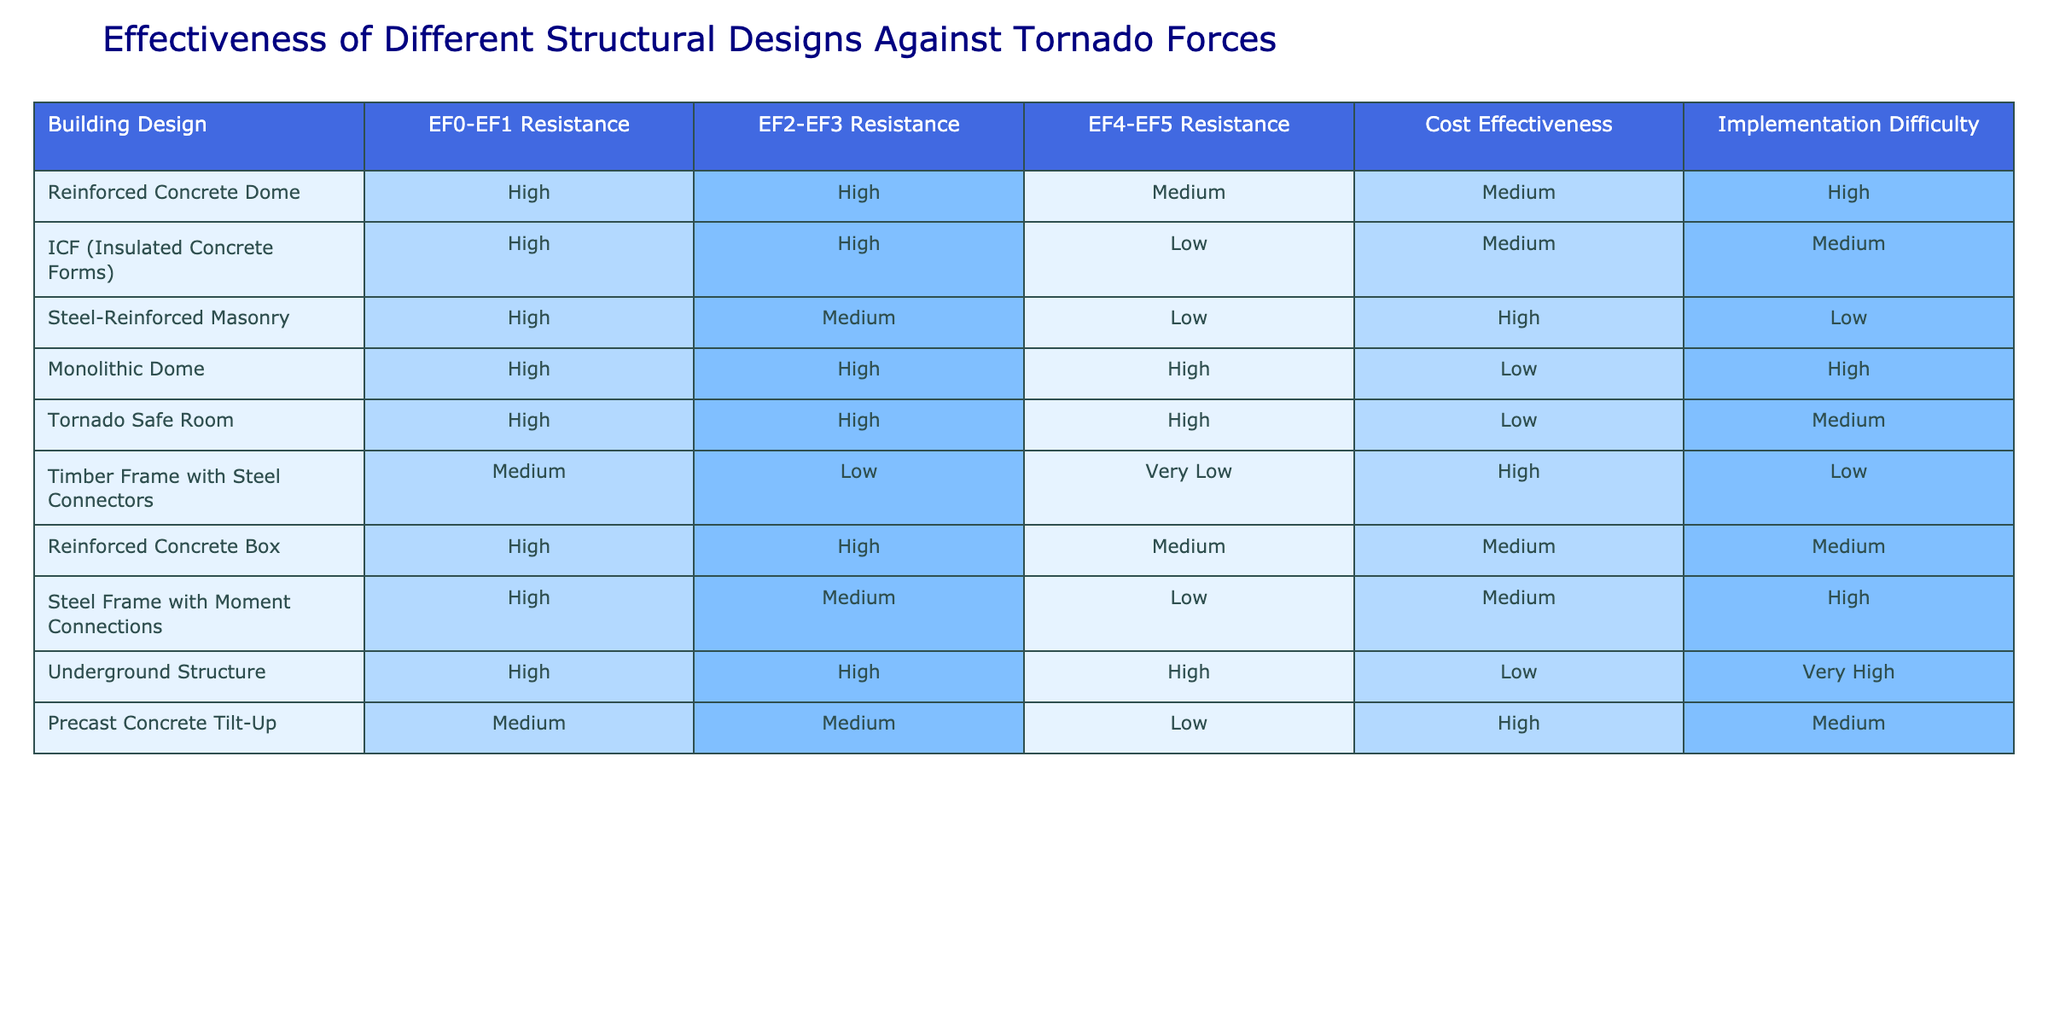What building design has the highest resistance against EF4-EF5 tornadoes? In the table, "Monolithic Dome", "Tornado Safe Room", and "Underground Structure" all have "High" resistance against EF4-EF5 tornadoes, which is the best rating.
Answer: Monolithic Dome, Tornado Safe Room, Underground Structure Which design is most cost-effective while maintaining high resistance against lower tornado forces (EF0-EF1)? The "Steel-Reinforced Masonry" design has "High" resistance against EF0-EF1 tornadoes and "High" cost effectiveness based on the table.
Answer: Steel-Reinforced Masonry Is there any building design that has low implementation difficulty and medium cost effectiveness? In the table, the "Reinforced Concrete Box" design has "Medium" implementation difficulty and "Medium" cost effectiveness.
Answer: Yes What is the difference in resistance between the "Reinforced Concrete Dome" and "Timber Frame with Steel Connectors" for EF2-EF3 tornadoes? The "Reinforced Concrete Dome" has "High" resistance while the "Timber Frame with Steel Connectors" has "Low" resistance for EF2-EF3 tornadoes. The difference is High - Low, or essentially, one design has significantly better resistance.
Answer: High Which structural design is the easiest to implement among all those listed? I need to identify the designs with "Low" or "Medium" implementation difficulty. The "Steel-Reinforced Masonry" has the lowest difficulty rating of "Low", while others like "Reinforced Concrete Dome" and "Wood Frame with Steel Connectors" have "High".
Answer: Steel-Reinforced Masonry How many designs have high resistance to EF0-EF1 tornadoes and also high resistance to EF2-EF3 tornadoes? The designs that have both high ratings for EF0-EF1 and EF2-EF3 are "Reinforced Concrete Dome", "ICF", "Monolithic Dome", "Tornado Safe Room", and "Reinforced Concrete Box". That makes a total of five designs meeting this criteria.
Answer: 5 Which building design offers the best overall tornado resistance without a significant rise in costs? Comparing the designs, "Monolithic Dome" and "Tornado Safe Room" have "High" resistance across all categories and low cost effectiveness, whereas "Steel-Reinforced Masonry" has high rating and high cost effectiveness. Thus, no design seems to balance high resistance with cost medium efficiently. Therefore, "Steel-Reinforced Masonry" would be the best answer in terms of resistance and costs overall.
Answer: Steel-Reinforced Masonry What designs provide low resistance to EF4-EF5 tornado forces but high cost-effectiveness? The "Timber Frame with Steel Connectors" and "Precast Concrete Tilt-Up" both offer "Very Low" and "Low" resistance against EF4-EF5 tornado forces, respectively, yet they maintain high cost effectiveness.
Answer: Timber Frame with Steel Connectors, Precast Concrete Tilt-Up What percentage of the building designs are classified as having high resistance to EF0-EF1 tornadoes? Out of ten designs in the table, seven have "High" resistance to EF0-EF1. This equates to 70% of the designs. (7/10)*100 = 70%.
Answer: 70% 